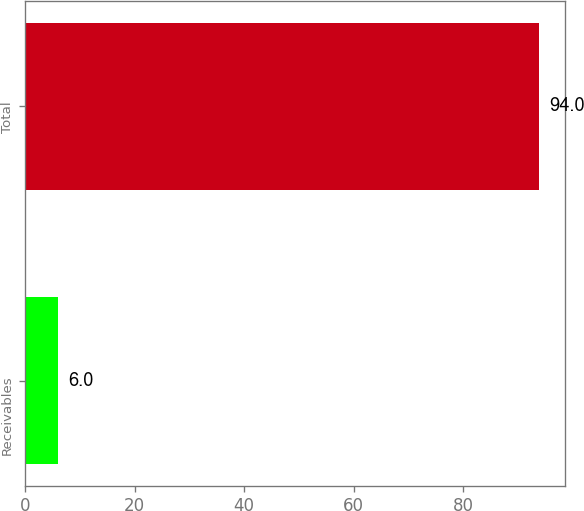Convert chart to OTSL. <chart><loc_0><loc_0><loc_500><loc_500><bar_chart><fcel>Receivables<fcel>Total<nl><fcel>6<fcel>94<nl></chart> 